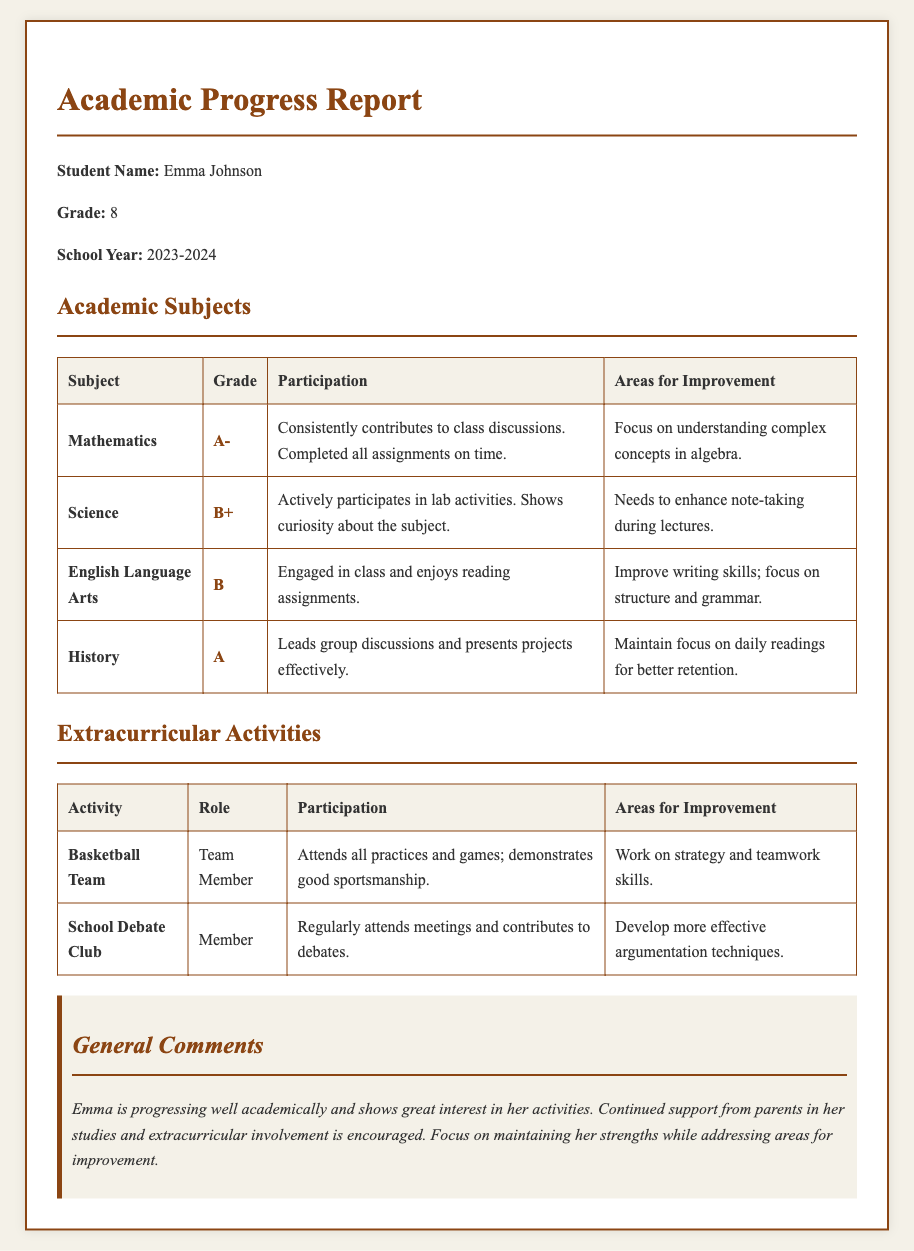What grade did Emma receive in Mathematics? The grade for Mathematics is stated directly in the report under the subject section.
Answer: A- What are the areas for improvement in English Language Arts? The report specifies the areas for improvement under each subject, including English Language Arts.
Answer: Improve writing skills; focus on structure and grammar How does Emma participate in lab activities for Science? Participation details are provided in the table for each subject, highlighting Emma's involvement in Science.
Answer: Actively participates in lab activities What role does Emma have in the Basketball Team? Each extracurricular activity includes a column for the role of the student which identifies Emma's position in the Basketball Team.
Answer: Team Member What grade did Emma receive for History? The grade for History is indicated in the Academic Subjects table, showing her performance in that subject.
Answer: A What is Emma's overall progress in her academic subjects according to general comments? The general comments summarize the student's performance across subjects and highlight overall progress.
Answer: Progressing well academically What extracurricular activity does Emma regularly contribute to? The report lists extracurricular activities with descriptions of involvement; one shows her consistent contribution.
Answer: School Debate Club What strategy is suggested for Emma in her Basketball Team participation? The areas for improvement provide guidance for Emma's development in sports activities, focusing on teamwork.
Answer: Work on strategy and teamwork skills 